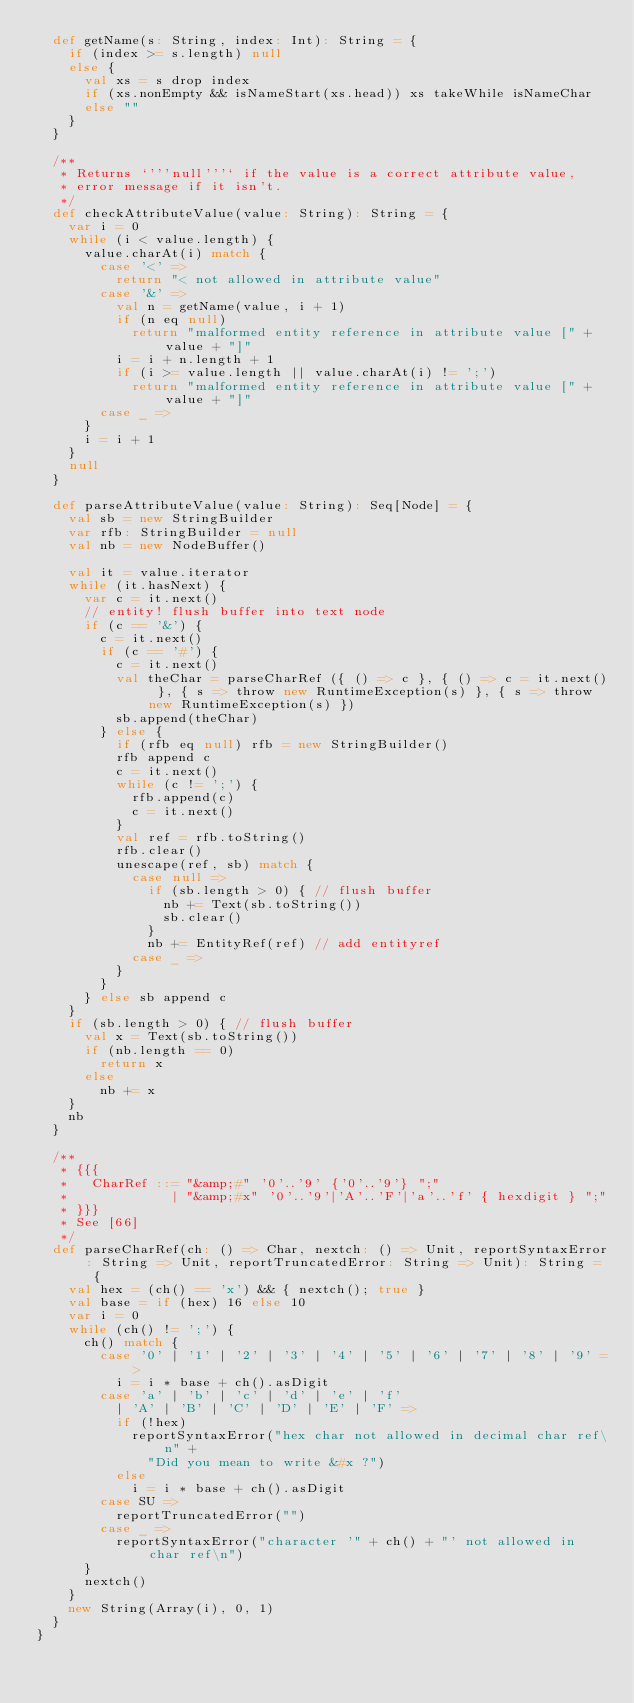<code> <loc_0><loc_0><loc_500><loc_500><_Scala_>  def getName(s: String, index: Int): String = {
    if (index >= s.length) null
    else {
      val xs = s drop index
      if (xs.nonEmpty && isNameStart(xs.head)) xs takeWhile isNameChar
      else ""
    }
  }

  /**
   * Returns `'''null'''` if the value is a correct attribute value,
   * error message if it isn't.
   */
  def checkAttributeValue(value: String): String = {
    var i = 0
    while (i < value.length) {
      value.charAt(i) match {
        case '<' =>
          return "< not allowed in attribute value"
        case '&' =>
          val n = getName(value, i + 1)
          if (n eq null)
            return "malformed entity reference in attribute value [" + value + "]"
          i = i + n.length + 1
          if (i >= value.length || value.charAt(i) != ';')
            return "malformed entity reference in attribute value [" + value + "]"
        case _ =>
      }
      i = i + 1
    }
    null
  }

  def parseAttributeValue(value: String): Seq[Node] = {
    val sb = new StringBuilder
    var rfb: StringBuilder = null
    val nb = new NodeBuffer()

    val it = value.iterator
    while (it.hasNext) {
      var c = it.next()
      // entity! flush buffer into text node
      if (c == '&') {
        c = it.next()
        if (c == '#') {
          c = it.next()
          val theChar = parseCharRef ({ () => c }, { () => c = it.next() }, { s => throw new RuntimeException(s) }, { s => throw new RuntimeException(s) })
          sb.append(theChar)
        } else {
          if (rfb eq null) rfb = new StringBuilder()
          rfb append c
          c = it.next()
          while (c != ';') {
            rfb.append(c)
            c = it.next()
          }
          val ref = rfb.toString()
          rfb.clear()
          unescape(ref, sb) match {
            case null =>
              if (sb.length > 0) { // flush buffer
                nb += Text(sb.toString())
                sb.clear()
              }
              nb += EntityRef(ref) // add entityref
            case _ =>
          }
        }
      } else sb append c
    }
    if (sb.length > 0) { // flush buffer
      val x = Text(sb.toString())
      if (nb.length == 0)
        return x
      else
        nb += x
    }
    nb
  }

  /**
   * {{{
   *   CharRef ::= "&amp;#" '0'..'9' {'0'..'9'} ";"
   *             | "&amp;#x" '0'..'9'|'A'..'F'|'a'..'f' { hexdigit } ";"
   * }}}
   * See [66]
   */
  def parseCharRef(ch: () => Char, nextch: () => Unit, reportSyntaxError: String => Unit, reportTruncatedError: String => Unit): String = {
    val hex = (ch() == 'x') && { nextch(); true }
    val base = if (hex) 16 else 10
    var i = 0
    while (ch() != ';') {
      ch() match {
        case '0' | '1' | '2' | '3' | '4' | '5' | '6' | '7' | '8' | '9' =>
          i = i * base + ch().asDigit
        case 'a' | 'b' | 'c' | 'd' | 'e' | 'f'
          | 'A' | 'B' | 'C' | 'D' | 'E' | 'F' =>
          if (!hex)
            reportSyntaxError("hex char not allowed in decimal char ref\n" +
              "Did you mean to write &#x ?")
          else
            i = i * base + ch().asDigit
        case SU =>
          reportTruncatedError("")
        case _ =>
          reportSyntaxError("character '" + ch() + "' not allowed in char ref\n")
      }
      nextch()
    }
    new String(Array(i), 0, 1)
  }
}
</code> 